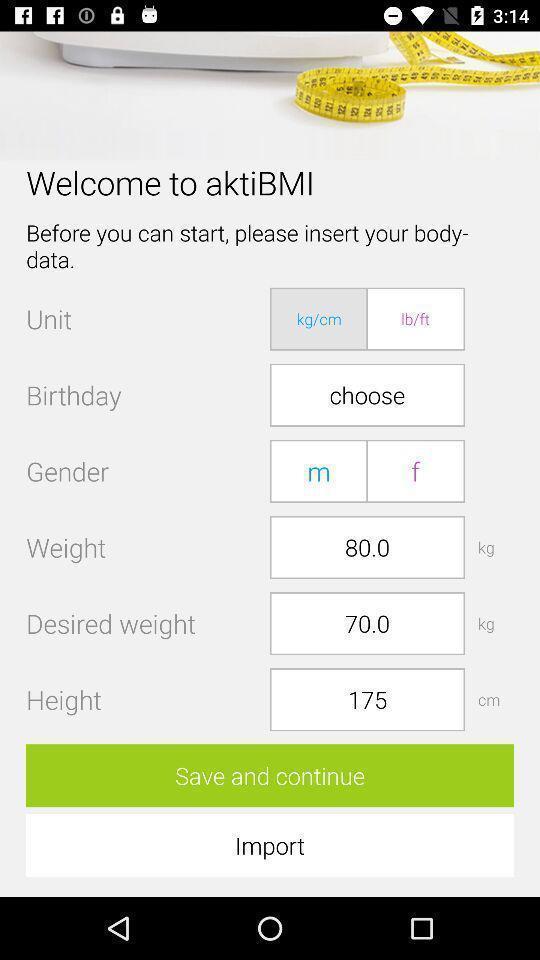Give me a narrative description of this picture. Welcome screen of fitness app asking personal information. 